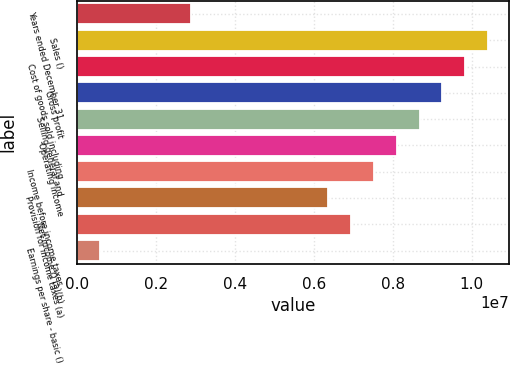Convert chart to OTSL. <chart><loc_0><loc_0><loc_500><loc_500><bar_chart><fcel>Years ended December 31<fcel>Sales ()<fcel>Cost of goods sold including<fcel>Gross profit<fcel>Selling general and<fcel>Operating income<fcel>Income before income taxes<fcel>Provision for income taxes (a)<fcel>Net income () (a)(b)<fcel>Earnings per share - basic ()<nl><fcel>2.89441e+06<fcel>1.04199e+07<fcel>9.84098e+06<fcel>9.2621e+06<fcel>8.68322e+06<fcel>8.10434e+06<fcel>7.52546e+06<fcel>6.3677e+06<fcel>6.94658e+06<fcel>578885<nl></chart> 